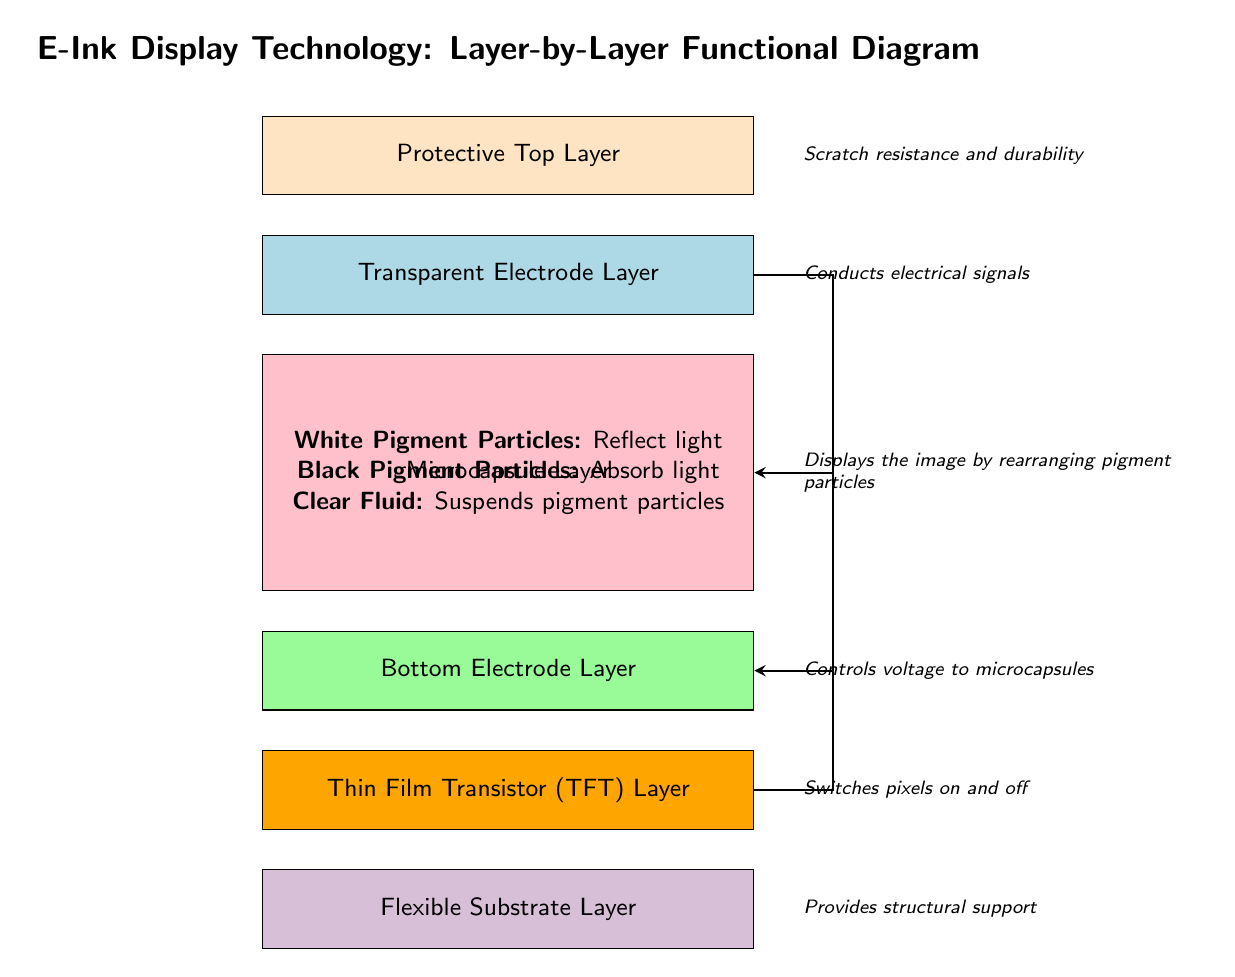What is the top layer in the diagram? The top layer is labeled as "Protective Top Layer" in the diagram.
Answer: Protective Top Layer What is the function of the Transparent Electrode Layer? The Transparent Electrode Layer is annotated with "Conducts electrical signals."
Answer: Conducts electrical signals How many layers are present in the diagram? The diagram shows a total of six layers.
Answer: Six Which layer rearranges pigment particles to display the image? The Microcapsule Layer is identified as the one that "Displays the image by rearranging pigment particles."
Answer: Microcapsule Layer What is the primary role of the Thin Film Transistor (TFT) Layer? The annotation next to this layer states that it "Switches pixels on and off."
Answer: Switches pixels on and off Which layer provides structural support? The Flexible Substrate Layer is described as providing "Structural support."
Answer: Flexible Substrate Layer How do the white pigment particles interact with light? The description indicates that white pigment particles "Reflect light."
Answer: Reflect light What does the Bottom Electrode Layer control? This layer is annotated to "Controls voltage to microcapsules."
Answer: Controls voltage Which layer is responsible for scratch resistance? The diagram states that the Protective Top Layer is "Scratch resistance and durability."
Answer: Scratch resistance and durability 